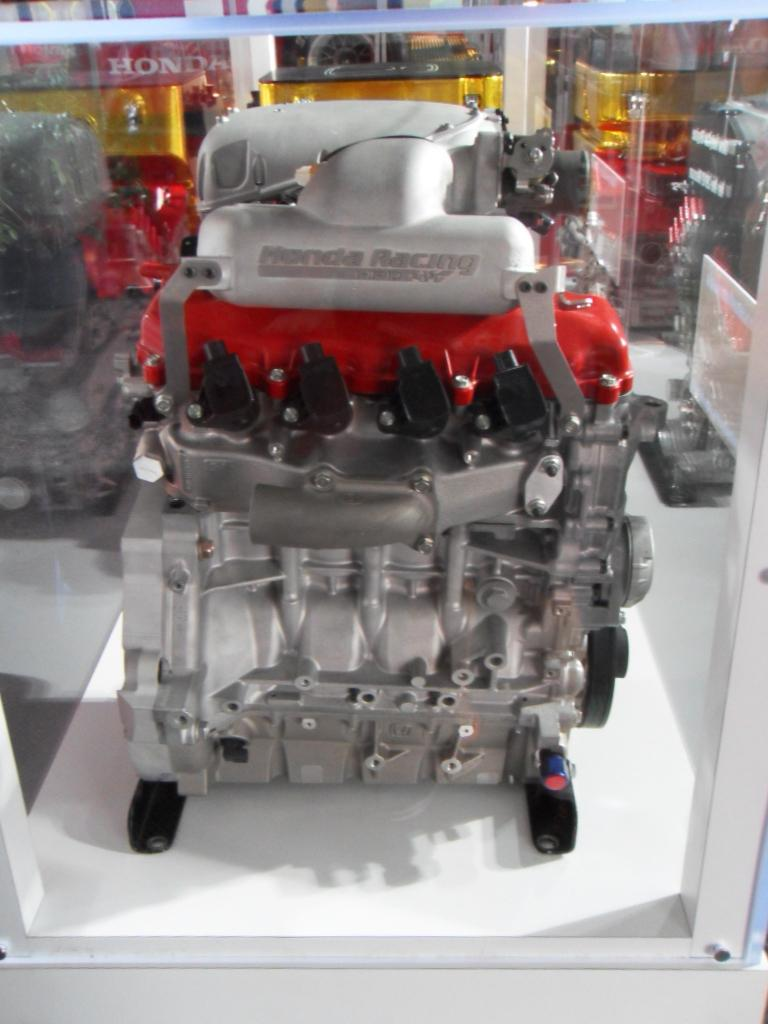What is the main subject of the image? The main subject of the image is a model of a machine motor. How is the model displayed in the image? The model is kept inside a glass box. How many trains can be seen passing by the model in the image? There are no trains visible in the image; it only features a model of a machine motor inside a glass box. 